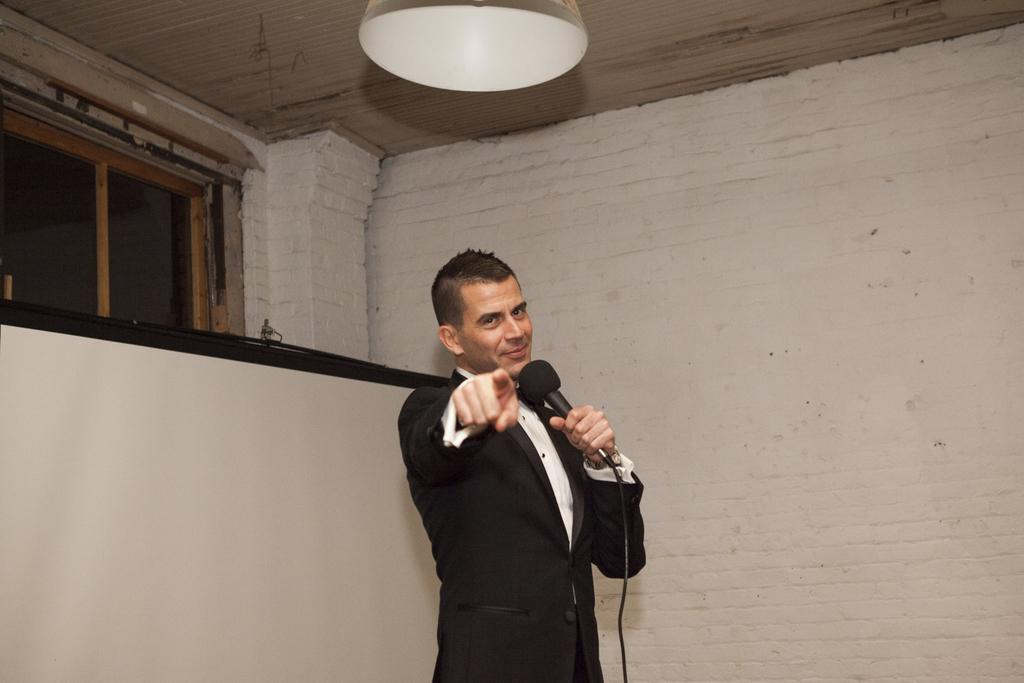Who is present in the image? There is a man in the image. What is the man doing in the image? The man is smiling and holding a microphone. What else can be seen in the image? There is a projector screen visible in the image. What type of wren can be seen perched on the microphone in the image? There is no wren present in the image; the man is holding a microphone, but there are no birds visible. How many watches can be seen on the man's wrist in the image? There is no watch visible on the man's wrist in the image. 